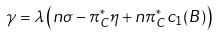Convert formula to latex. <formula><loc_0><loc_0><loc_500><loc_500>\gamma = \lambda \left ( n \sigma - \pi _ { C } ^ { * } \eta + n \pi _ { C } ^ { * } c _ { 1 } ( B ) \right )</formula> 